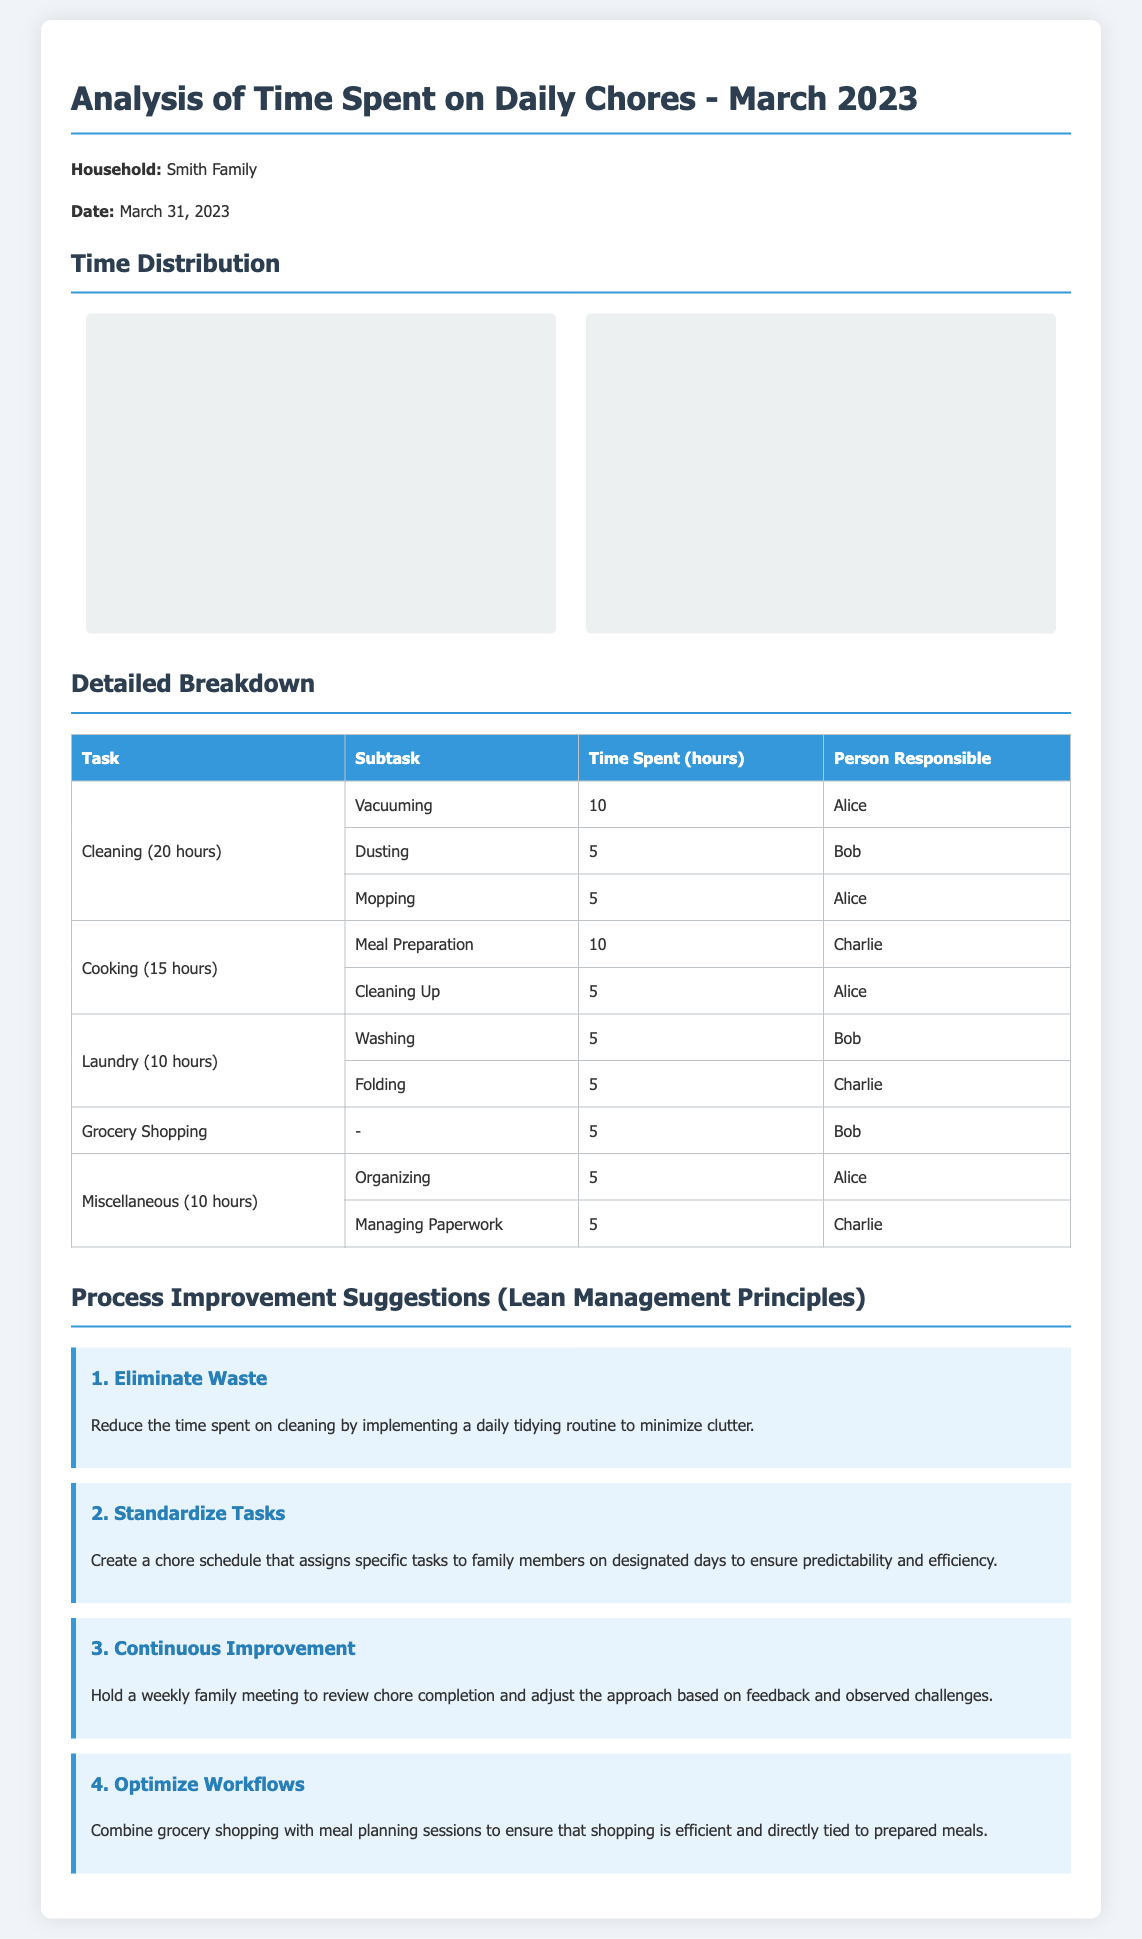What is the total time spent on cleaning? The total time spent on cleaning is indicated in the breakdown as 20 hours.
Answer: 20 hours Who is responsible for mopping? The detailed breakdown specifies that Alice is responsible for mopping.
Answer: Alice How many hours did Charlie spend on cooking? Charlie's time spent on cooking is detailed as 10 hours for meal preparation and 0 for cleaning up, totaling 10 hours.
Answer: 10 hours What task took the most time in March 2023? The document shows that cleaning, with a total of 20 hours, took the most time.
Answer: Cleaning How many people shared the chores? The analysis shows that chores were shared among three people: Alice, Bob, and Charlie.
Answer: Three What improvement suggests a weekly review of chores? The improvement suggestion focused on continuous improvement recommends holding a weekly family meeting for review.
Answer: Continuous Improvement How many hours were spent on grocery shopping? The detailed breakdown states that 5 hours were spent on grocery shopping.
Answer: 5 hours Which task had the least amount of time spent? The task with the least amount of time spent is grocery shopping, which took 5 hours.
Answer: Grocery Shopping 